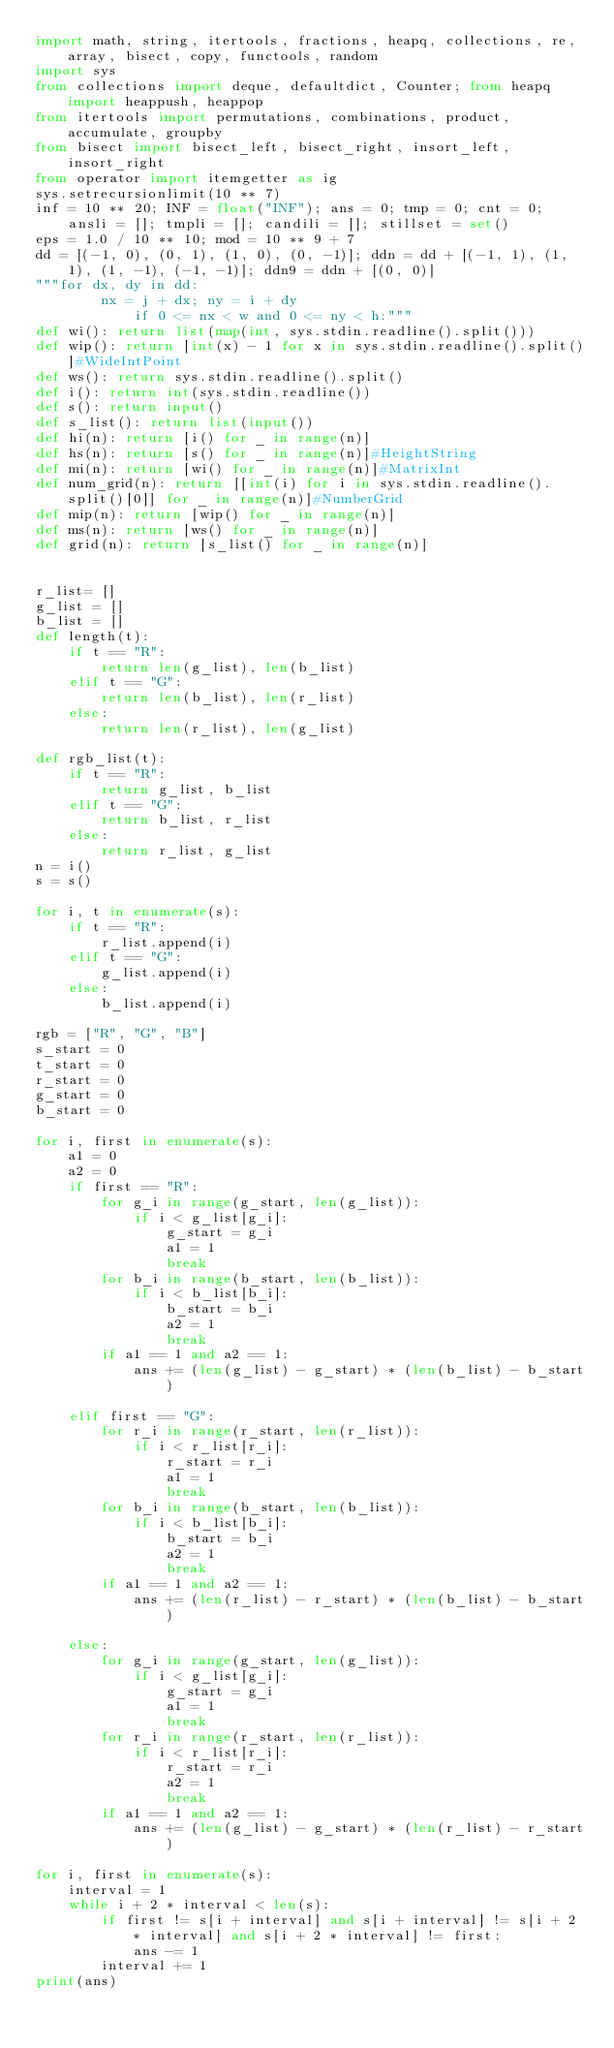<code> <loc_0><loc_0><loc_500><loc_500><_Python_>import math, string, itertools, fractions, heapq, collections, re, array, bisect, copy, functools, random
import sys
from collections import deque, defaultdict, Counter; from heapq import heappush, heappop
from itertools import permutations, combinations, product, accumulate, groupby
from bisect import bisect_left, bisect_right, insort_left, insort_right
from operator import itemgetter as ig
sys.setrecursionlimit(10 ** 7)
inf = 10 ** 20; INF = float("INF"); ans = 0; tmp = 0; cnt = 0; ansli = []; tmpli = []; candili = []; stillset = set()
eps = 1.0 / 10 ** 10; mod = 10 ** 9 + 7
dd = [(-1, 0), (0, 1), (1, 0), (0, -1)]; ddn = dd + [(-1, 1), (1, 1), (1, -1), (-1, -1)]; ddn9 = ddn + [(0, 0)]
"""for dx, dy in dd:
        nx = j + dx; ny = i + dy
            if 0 <= nx < w and 0 <= ny < h:"""
def wi(): return list(map(int, sys.stdin.readline().split()))
def wip(): return [int(x) - 1 for x in sys.stdin.readline().split()]#WideIntPoint
def ws(): return sys.stdin.readline().split()
def i(): return int(sys.stdin.readline())
def s(): return input()
def s_list(): return list(input())
def hi(n): return [i() for _ in range(n)]
def hs(n): return [s() for _ in range(n)]#HeightString
def mi(n): return [wi() for _ in range(n)]#MatrixInt
def num_grid(n): return [[int(i) for i in sys.stdin.readline().split()[0]] for _ in range(n)]#NumberGrid
def mip(n): return [wip() for _ in range(n)]
def ms(n): return [ws() for _ in range(n)]
def grid(n): return [s_list() for _ in range(n)]


r_list= []
g_list = []
b_list = []
def length(t):
    if t == "R":
        return len(g_list), len(b_list)
    elif t == "G":
        return len(b_list), len(r_list)
    else:
        return len(r_list), len(g_list)

def rgb_list(t):
    if t == "R":
        return g_list, b_list
    elif t == "G":
        return b_list, r_list
    else:
        return r_list, g_list
n = i()
s = s()

for i, t in enumerate(s):
    if t == "R":
        r_list.append(i)
    elif t == "G":
        g_list.append(i)
    else:
        b_list.append(i)

rgb = ["R", "G", "B"]
s_start = 0
t_start = 0
r_start = 0
g_start = 0
b_start = 0

for i, first in enumerate(s):
    a1 = 0
    a2 = 0
    if first == "R":
        for g_i in range(g_start, len(g_list)):
            if i < g_list[g_i]:
                g_start = g_i
                a1 = 1
                break
        for b_i in range(b_start, len(b_list)):
            if i < b_list[b_i]:
                b_start = b_i
                a2 = 1
                break
        if a1 == 1 and a2 == 1:
            ans += (len(g_list) - g_start) * (len(b_list) - b_start)

    elif first == "G":
        for r_i in range(r_start, len(r_list)):
            if i < r_list[r_i]:
                r_start = r_i
                a1 = 1
                break
        for b_i in range(b_start, len(b_list)):
            if i < b_list[b_i]:
                b_start = b_i
                a2 = 1
                break
        if a1 == 1 and a2 == 1:
            ans += (len(r_list) - r_start) * (len(b_list) - b_start)

    else:
        for g_i in range(g_start, len(g_list)):
            if i < g_list[g_i]:
                g_start = g_i
                a1 = 1
                break
        for r_i in range(r_start, len(r_list)):
            if i < r_list[r_i]:
                r_start = r_i
                a2 = 1
                break
        if a1 == 1 and a2 == 1:
            ans += (len(g_list) - g_start) * (len(r_list) - r_start)

for i, first in enumerate(s):
    interval = 1
    while i + 2 * interval < len(s):
        if first != s[i + interval] and s[i + interval] != s[i + 2 * interval] and s[i + 2 * interval] != first:
            ans -= 1
        interval += 1
print(ans)</code> 